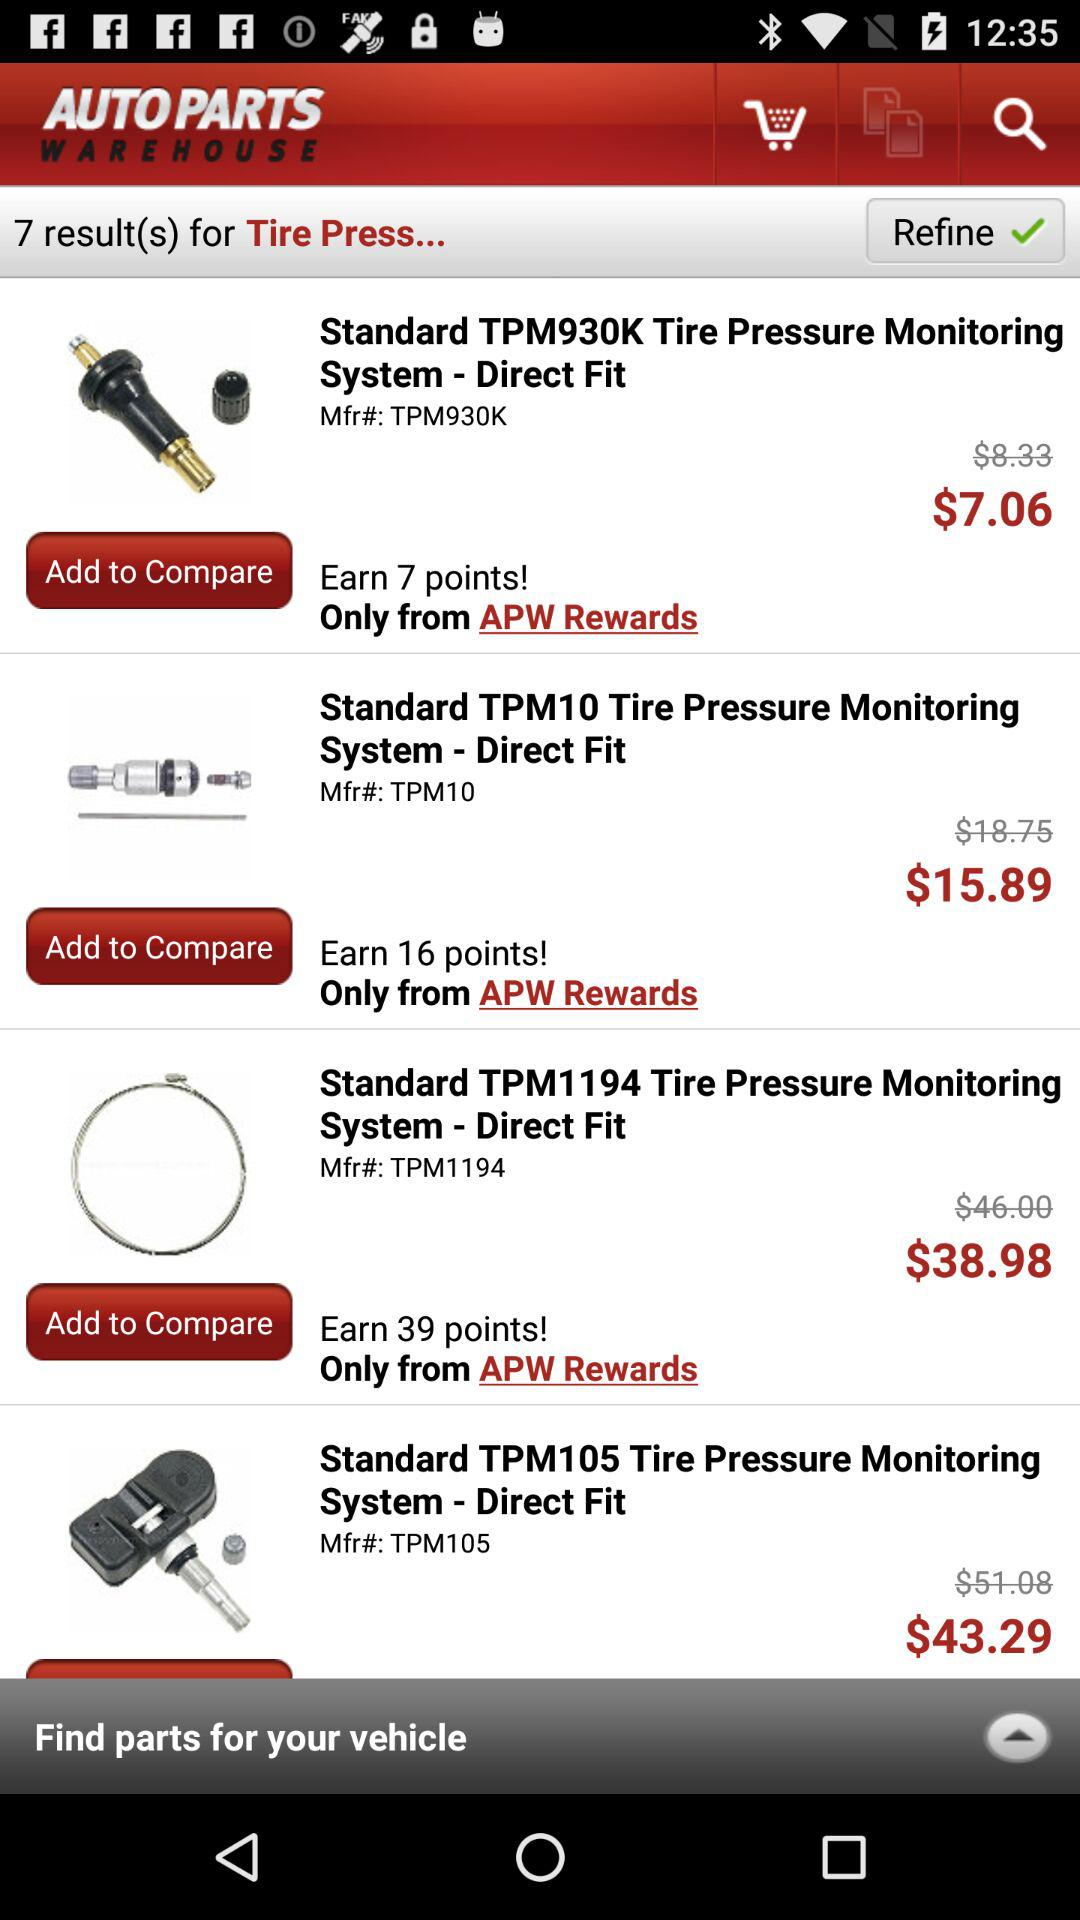What is the currency of price?
When the provided information is insufficient, respond with <no answer>. <no answer> 